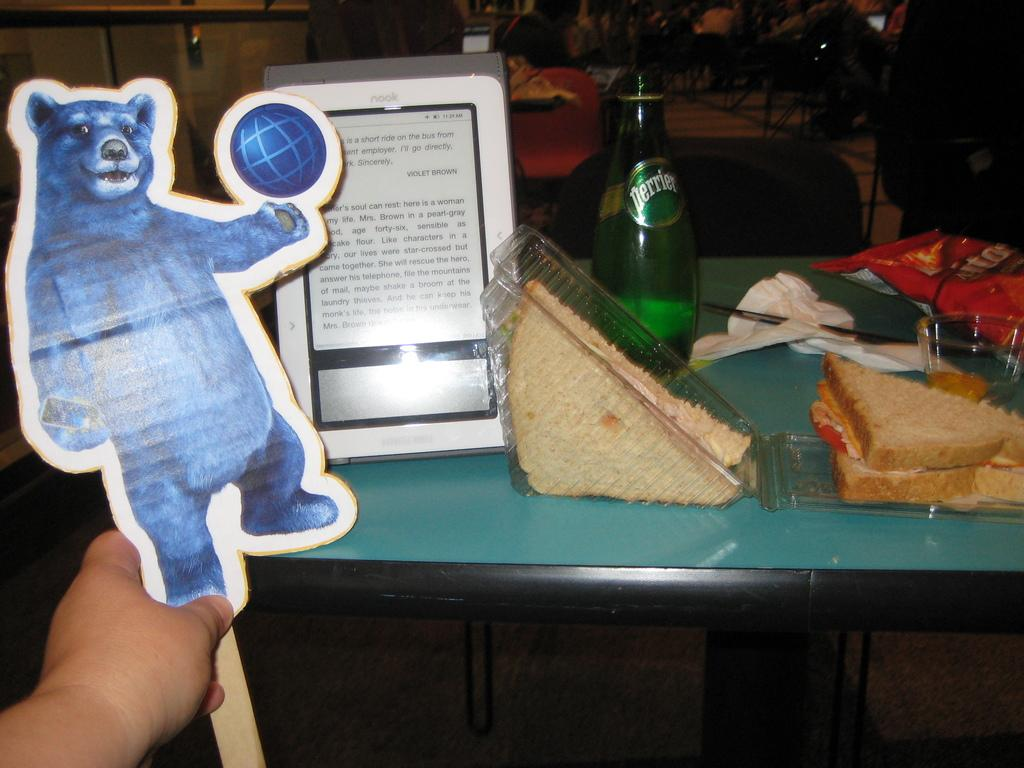<image>
Write a terse but informative summary of the picture. Person holding a cutout of a bear next to a bottle of beer saying PERRIER on it. 